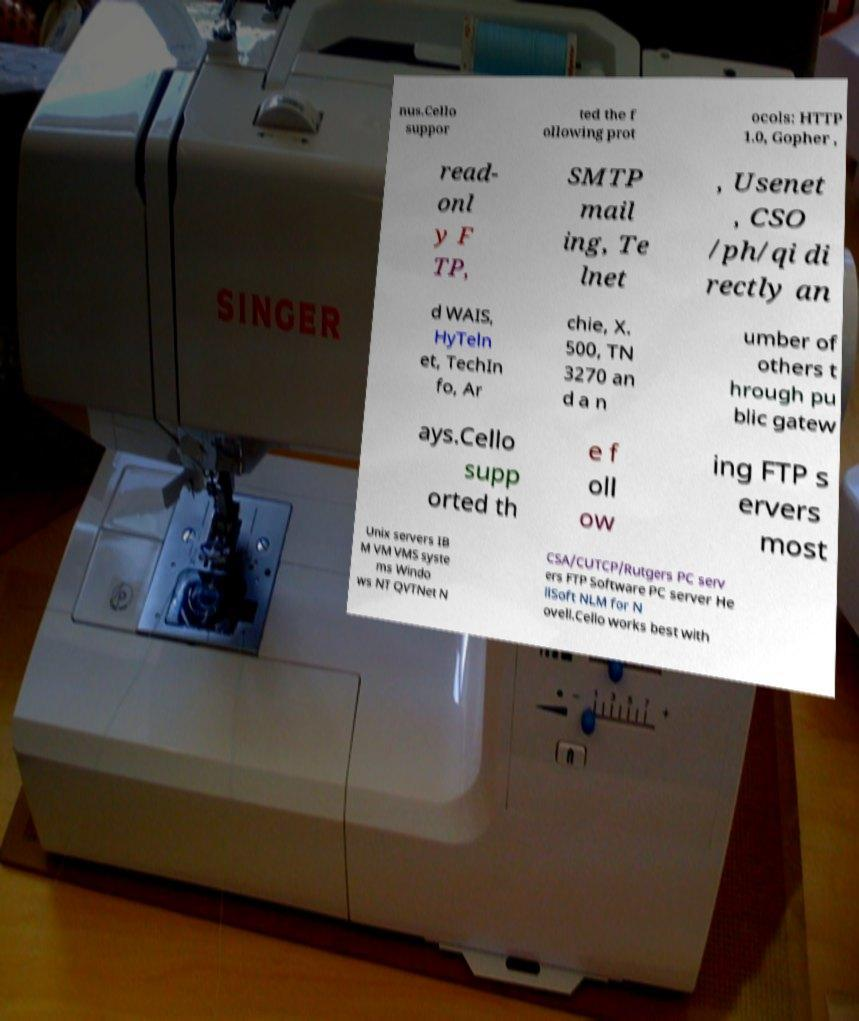What messages or text are displayed in this image? I need them in a readable, typed format. nus.Cello suppor ted the f ollowing prot ocols: HTTP 1.0, Gopher , read- onl y F TP, SMTP mail ing, Te lnet , Usenet , CSO /ph/qi di rectly an d WAIS, HyTeln et, TechIn fo, Ar chie, X. 500, TN 3270 an d a n umber of others t hrough pu blic gatew ays.Cello supp orted th e f oll ow ing FTP s ervers most Unix servers IB M VM VMS syste ms Windo ws NT QVTNet N CSA/CUTCP/Rutgers PC serv ers FTP Software PC server He llSoft NLM for N ovell.Cello works best with 